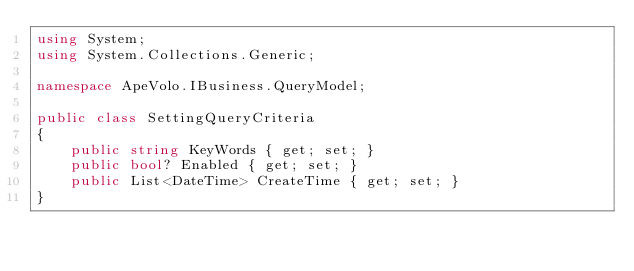<code> <loc_0><loc_0><loc_500><loc_500><_C#_>using System;
using System.Collections.Generic;

namespace ApeVolo.IBusiness.QueryModel;

public class SettingQueryCriteria
{
    public string KeyWords { get; set; }
    public bool? Enabled { get; set; }
    public List<DateTime> CreateTime { get; set; }
}</code> 